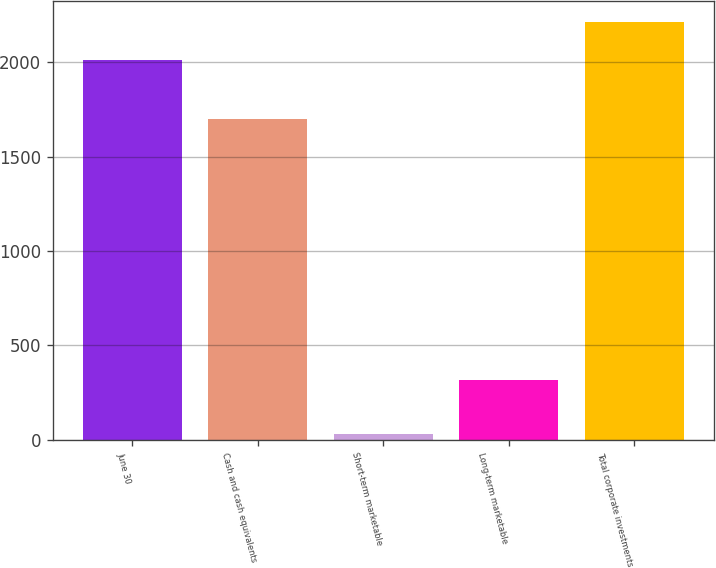Convert chart to OTSL. <chart><loc_0><loc_0><loc_500><loc_500><bar_chart><fcel>June 30<fcel>Cash and cash equivalents<fcel>Short-term marketable<fcel>Long-term marketable<fcel>Total corporate investments<nl><fcel>2013<fcel>1699.1<fcel>28<fcel>314<fcel>2214.31<nl></chart> 